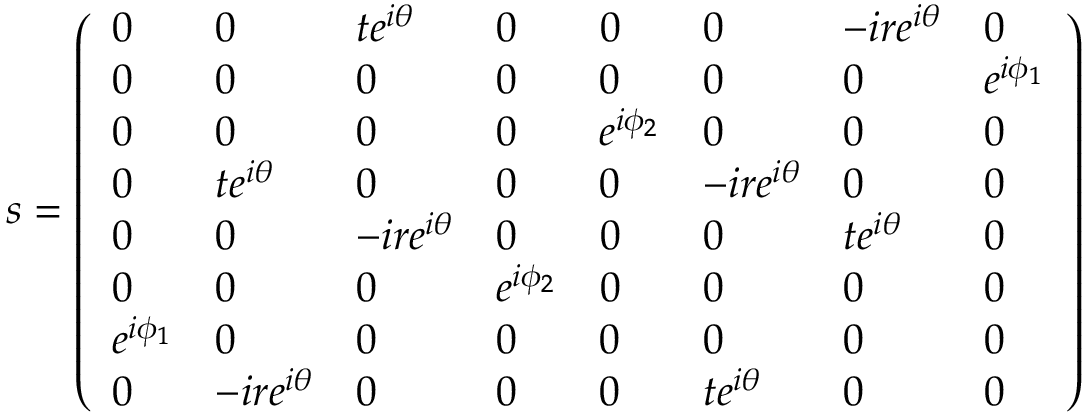Convert formula to latex. <formula><loc_0><loc_0><loc_500><loc_500>s = \left ( \begin{array} { l l l l l l l l } { 0 } & { 0 } & { t e ^ { i \theta } } & { 0 } & { 0 } & { 0 } & { - i r e ^ { i \theta } } & { 0 } \\ { 0 } & { 0 } & { 0 } & { 0 } & { 0 } & { 0 } & { 0 } & { e ^ { i \phi _ { 1 } } } \\ { 0 } & { 0 } & { 0 } & { 0 } & { e ^ { i \phi _ { 2 } } } & { 0 } & { 0 } & { 0 } \\ { 0 } & { t e ^ { i \theta } } & { 0 } & { 0 } & { 0 } & { - i r e ^ { i \theta } } & { 0 } & { 0 } \\ { 0 } & { 0 } & { - i r e ^ { i \theta } } & { 0 } & { 0 } & { 0 } & { t e ^ { i \theta } } & { 0 } \\ { 0 } & { 0 } & { 0 } & { e ^ { i \phi _ { 2 } } } & { 0 } & { 0 } & { 0 } & { 0 } \\ { e ^ { i \phi _ { 1 } } } & { 0 } & { 0 } & { 0 } & { 0 } & { 0 } & { 0 } & { 0 } \\ { 0 } & { - i r e ^ { i \theta } } & { 0 } & { 0 } & { 0 } & { t e ^ { i \theta } } & { 0 } & { 0 } \end{array} \right )</formula> 